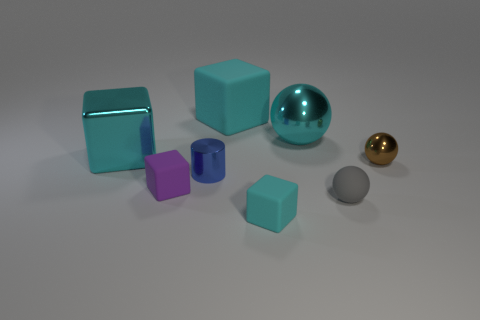Are the gray object and the brown sphere made of the same material?
Your response must be concise. No. What color is the object that is behind the large metal cube and right of the small cyan rubber object?
Provide a succinct answer. Cyan. Are there any cyan metal spheres of the same size as the brown metal ball?
Keep it short and to the point. No. There is a brown thing that is in front of the large object right of the large matte cube; how big is it?
Make the answer very short. Small. Is the number of matte cubes behind the tiny shiny cylinder less than the number of rubber blocks?
Provide a succinct answer. Yes. Do the big metal sphere and the small shiny cylinder have the same color?
Ensure brevity in your answer.  No. How big is the gray matte sphere?
Provide a succinct answer. Small. How many big matte blocks are the same color as the big ball?
Your answer should be compact. 1. Are there any cubes in front of the cyan rubber block that is on the right side of the cyan rubber cube that is behind the large cyan metal ball?
Your answer should be compact. No. There is a gray matte thing that is the same size as the brown thing; what is its shape?
Your answer should be very brief. Sphere. 